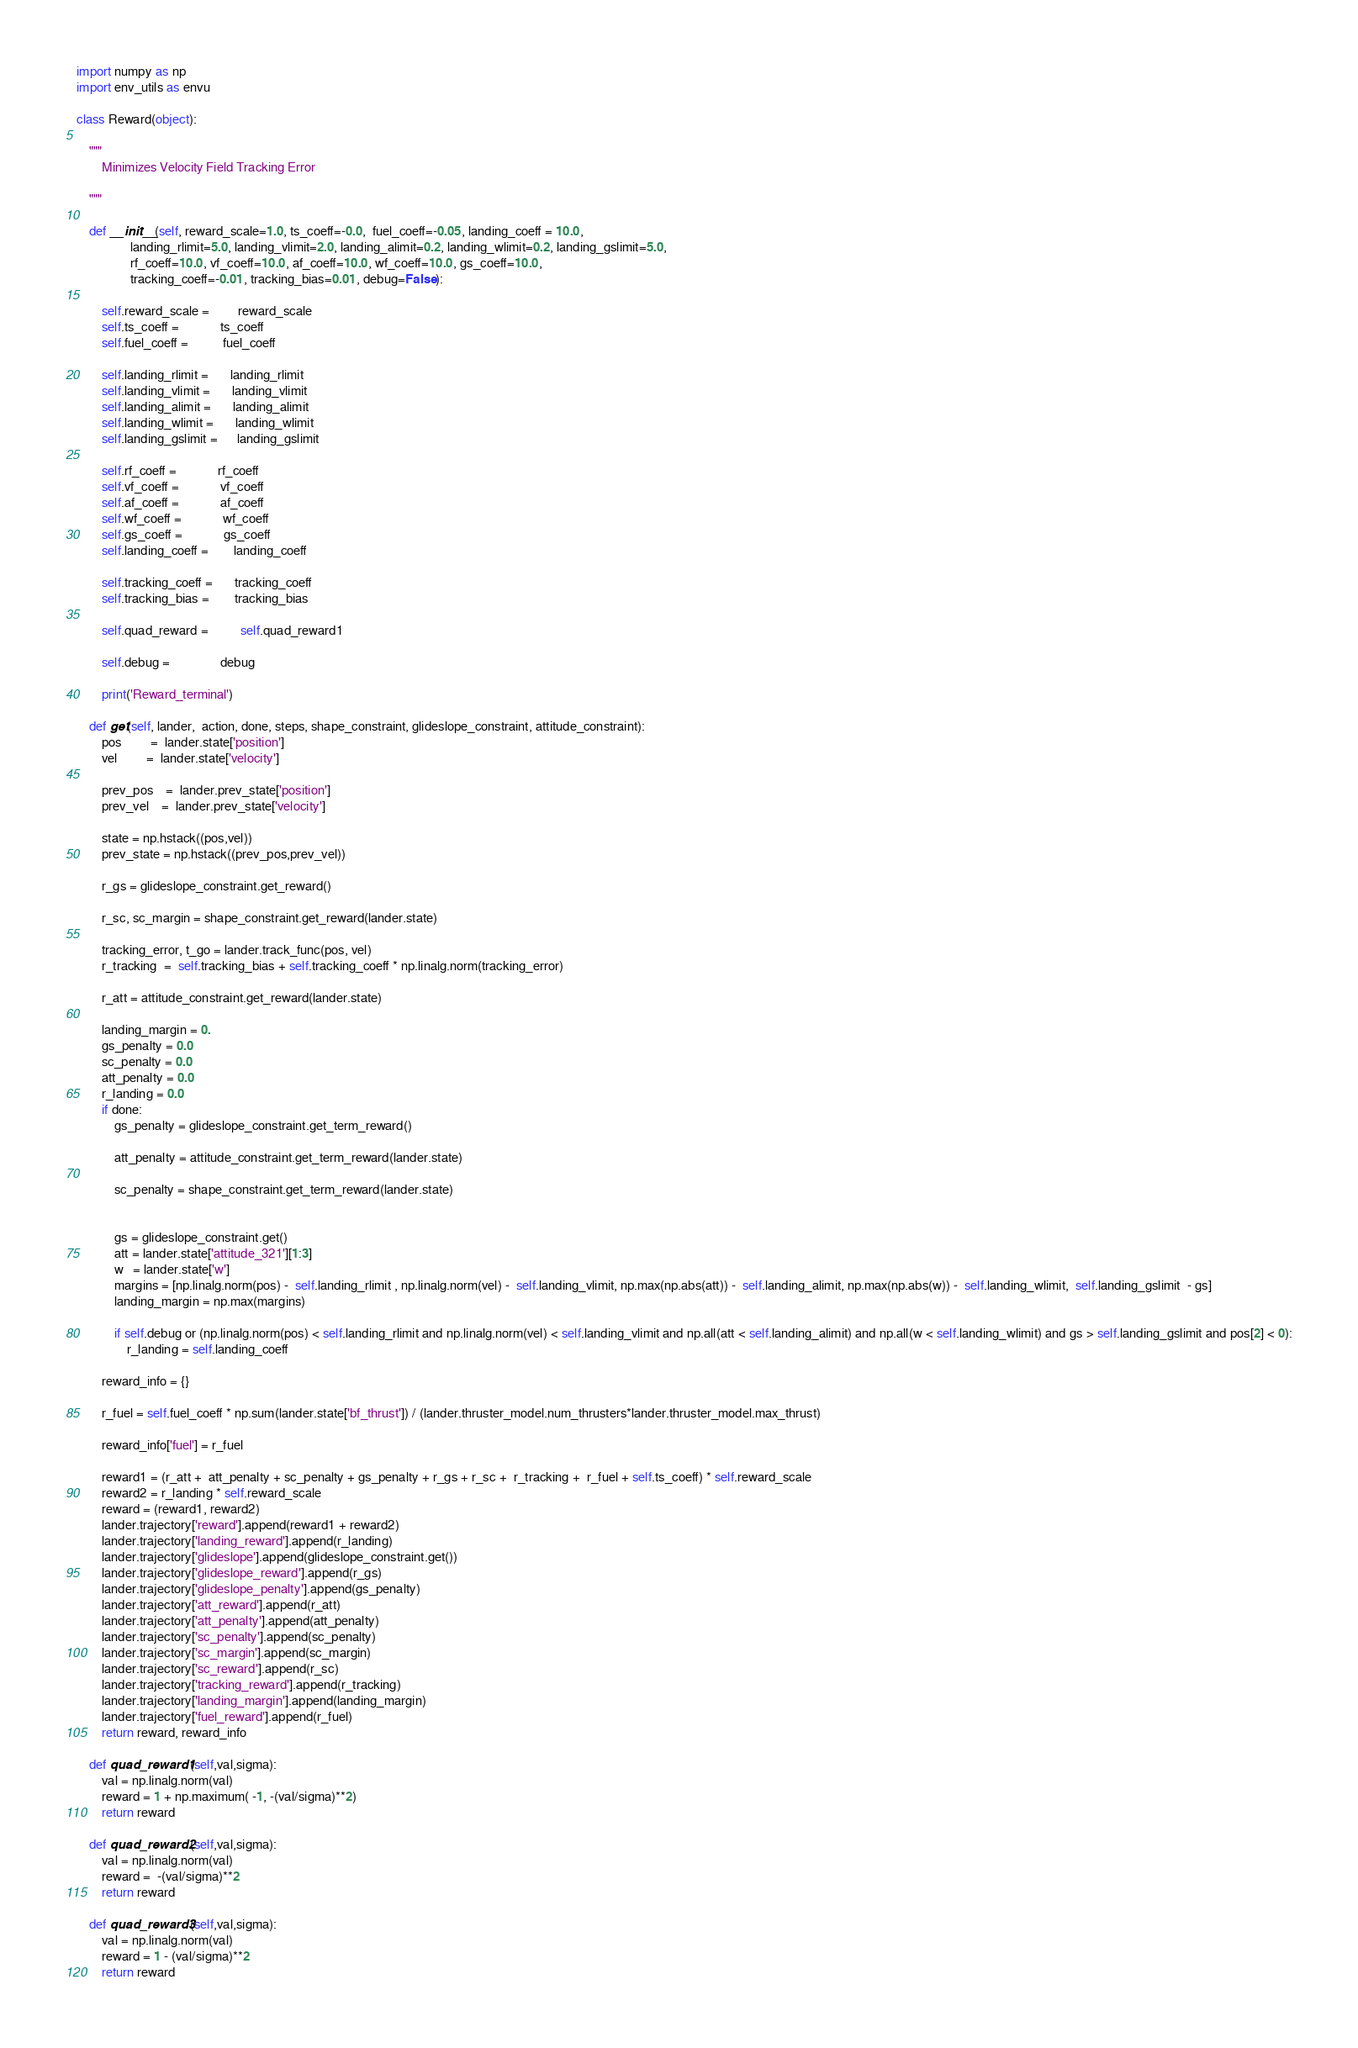Convert code to text. <code><loc_0><loc_0><loc_500><loc_500><_Python_>import numpy as np
import env_utils as envu

class Reward(object):

    """
        Minimizes Velocity Field Tracking Error

    """

    def __init__(self, reward_scale=1.0, ts_coeff=-0.0,  fuel_coeff=-0.05, landing_coeff = 10.0,
                 landing_rlimit=5.0, landing_vlimit=2.0, landing_alimit=0.2, landing_wlimit=0.2, landing_gslimit=5.0,
                 rf_coeff=10.0, vf_coeff=10.0, af_coeff=10.0, wf_coeff=10.0, gs_coeff=10.0,
                 tracking_coeff=-0.01, tracking_bias=0.01, debug=False):

        self.reward_scale =         reward_scale
        self.ts_coeff =             ts_coeff
        self.fuel_coeff =           fuel_coeff

        self.landing_rlimit =       landing_rlimit
        self.landing_vlimit =       landing_vlimit
        self.landing_alimit =       landing_alimit
        self.landing_wlimit =       landing_wlimit
        self.landing_gslimit =      landing_gslimit

        self.rf_coeff =             rf_coeff
        self.vf_coeff =             vf_coeff
        self.af_coeff =             af_coeff
        self.wf_coeff =             wf_coeff
        self.gs_coeff =             gs_coeff
        self.landing_coeff =        landing_coeff

        self.tracking_coeff =       tracking_coeff
        self.tracking_bias =        tracking_bias

        self.quad_reward =          self.quad_reward1

        self.debug =                debug

        print('Reward_terminal')

    def get(self, lander,  action, done, steps, shape_constraint, glideslope_constraint, attitude_constraint):
        pos         =  lander.state['position']
        vel         =  lander.state['velocity']

        prev_pos    =  lander.prev_state['position']
        prev_vel    =  lander.prev_state['velocity']

        state = np.hstack((pos,vel))
        prev_state = np.hstack((prev_pos,prev_vel))

        r_gs = glideslope_constraint.get_reward()

        r_sc, sc_margin = shape_constraint.get_reward(lander.state)

        tracking_error, t_go = lander.track_func(pos, vel)
        r_tracking  =  self.tracking_bias + self.tracking_coeff * np.linalg.norm(tracking_error)

        r_att = attitude_constraint.get_reward(lander.state)

        landing_margin = 0.
        gs_penalty = 0.0
        sc_penalty = 0.0
        att_penalty = 0.0
        r_landing = 0.0
        if done:
            gs_penalty = glideslope_constraint.get_term_reward()

            att_penalty = attitude_constraint.get_term_reward(lander.state)

            sc_penalty = shape_constraint.get_term_reward(lander.state)


            gs = glideslope_constraint.get()
            att = lander.state['attitude_321'][1:3]
            w   = lander.state['w']
            margins = [np.linalg.norm(pos) -  self.landing_rlimit , np.linalg.norm(vel) -  self.landing_vlimit, np.max(np.abs(att)) -  self.landing_alimit, np.max(np.abs(w)) -  self.landing_wlimit,  self.landing_gslimit  - gs]
            landing_margin = np.max(margins)

            if self.debug or (np.linalg.norm(pos) < self.landing_rlimit and np.linalg.norm(vel) < self.landing_vlimit and np.all(att < self.landing_alimit) and np.all(w < self.landing_wlimit) and gs > self.landing_gslimit and pos[2] < 0):
                r_landing = self.landing_coeff

        reward_info = {}

        r_fuel = self.fuel_coeff * np.sum(lander.state['bf_thrust']) / (lander.thruster_model.num_thrusters*lander.thruster_model.max_thrust)

        reward_info['fuel'] = r_fuel

        reward1 = (r_att +  att_penalty + sc_penalty + gs_penalty + r_gs + r_sc +  r_tracking +  r_fuel + self.ts_coeff) * self.reward_scale
        reward2 = r_landing * self.reward_scale
        reward = (reward1, reward2)
        lander.trajectory['reward'].append(reward1 + reward2)
        lander.trajectory['landing_reward'].append(r_landing)
        lander.trajectory['glideslope'].append(glideslope_constraint.get())
        lander.trajectory['glideslope_reward'].append(r_gs)
        lander.trajectory['glideslope_penalty'].append(gs_penalty)
        lander.trajectory['att_reward'].append(r_att)
        lander.trajectory['att_penalty'].append(att_penalty)
        lander.trajectory['sc_penalty'].append(sc_penalty)
        lander.trajectory['sc_margin'].append(sc_margin)
        lander.trajectory['sc_reward'].append(r_sc)
        lander.trajectory['tracking_reward'].append(r_tracking)
        lander.trajectory['landing_margin'].append(landing_margin)
        lander.trajectory['fuel_reward'].append(r_fuel)
        return reward, reward_info

    def quad_reward1(self,val,sigma):
        val = np.linalg.norm(val)
        reward = 1 + np.maximum( -1, -(val/sigma)**2)
        return reward

    def quad_reward2(self,val,sigma):
        val = np.linalg.norm(val)
        reward =  -(val/sigma)**2
        return reward

    def quad_reward3(self,val,sigma):
        val = np.linalg.norm(val)
        reward = 1 - (val/sigma)**2
        return reward

</code> 